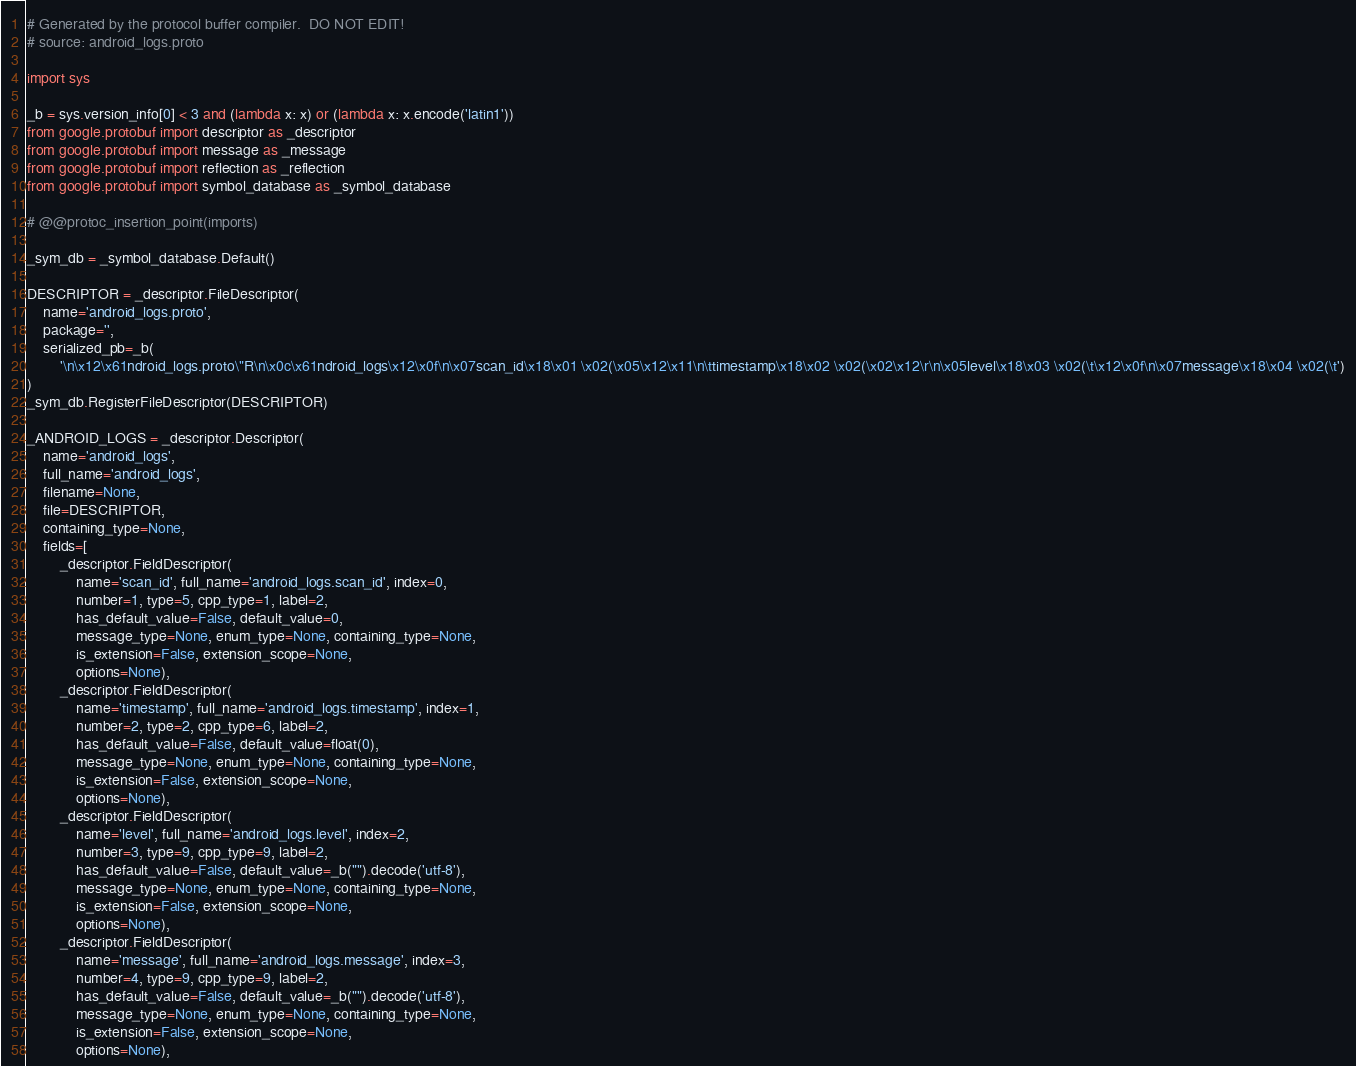Convert code to text. <code><loc_0><loc_0><loc_500><loc_500><_Python_># Generated by the protocol buffer compiler.  DO NOT EDIT!
# source: android_logs.proto

import sys

_b = sys.version_info[0] < 3 and (lambda x: x) or (lambda x: x.encode('latin1'))
from google.protobuf import descriptor as _descriptor
from google.protobuf import message as _message
from google.protobuf import reflection as _reflection
from google.protobuf import symbol_database as _symbol_database

# @@protoc_insertion_point(imports)

_sym_db = _symbol_database.Default()

DESCRIPTOR = _descriptor.FileDescriptor(
    name='android_logs.proto',
    package='',
    serialized_pb=_b(
        '\n\x12\x61ndroid_logs.proto\"R\n\x0c\x61ndroid_logs\x12\x0f\n\x07scan_id\x18\x01 \x02(\x05\x12\x11\n\ttimestamp\x18\x02 \x02(\x02\x12\r\n\x05level\x18\x03 \x02(\t\x12\x0f\n\x07message\x18\x04 \x02(\t')
)
_sym_db.RegisterFileDescriptor(DESCRIPTOR)

_ANDROID_LOGS = _descriptor.Descriptor(
    name='android_logs',
    full_name='android_logs',
    filename=None,
    file=DESCRIPTOR,
    containing_type=None,
    fields=[
        _descriptor.FieldDescriptor(
            name='scan_id', full_name='android_logs.scan_id', index=0,
            number=1, type=5, cpp_type=1, label=2,
            has_default_value=False, default_value=0,
            message_type=None, enum_type=None, containing_type=None,
            is_extension=False, extension_scope=None,
            options=None),
        _descriptor.FieldDescriptor(
            name='timestamp', full_name='android_logs.timestamp', index=1,
            number=2, type=2, cpp_type=6, label=2,
            has_default_value=False, default_value=float(0),
            message_type=None, enum_type=None, containing_type=None,
            is_extension=False, extension_scope=None,
            options=None),
        _descriptor.FieldDescriptor(
            name='level', full_name='android_logs.level', index=2,
            number=3, type=9, cpp_type=9, label=2,
            has_default_value=False, default_value=_b("").decode('utf-8'),
            message_type=None, enum_type=None, containing_type=None,
            is_extension=False, extension_scope=None,
            options=None),
        _descriptor.FieldDescriptor(
            name='message', full_name='android_logs.message', index=3,
            number=4, type=9, cpp_type=9, label=2,
            has_default_value=False, default_value=_b("").decode('utf-8'),
            message_type=None, enum_type=None, containing_type=None,
            is_extension=False, extension_scope=None,
            options=None),</code> 